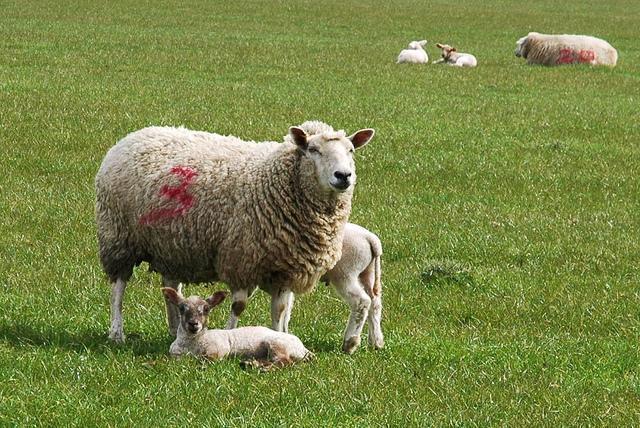What material do these animals provide for clothing?
Make your selection from the four choices given to correctly answer the question.
Options: Silk, wool, polyester, cotton. Wool. 